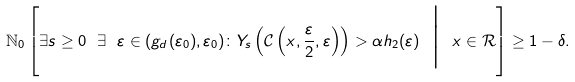<formula> <loc_0><loc_0><loc_500><loc_500>\mathbb { N } _ { 0 } \left [ \exists s \geq 0 \ \exists \ \varepsilon \in ( g _ { d } ( \varepsilon _ { 0 } ) , \varepsilon _ { 0 } ) \colon Y _ { s } \left ( \mathcal { C } \left ( x , \frac { \varepsilon } { 2 } , \varepsilon \right ) \right ) > \alpha h _ { 2 } ( \varepsilon ) \ \Big | \ x \in \mathcal { R } \right ] \geq 1 - \delta .</formula> 